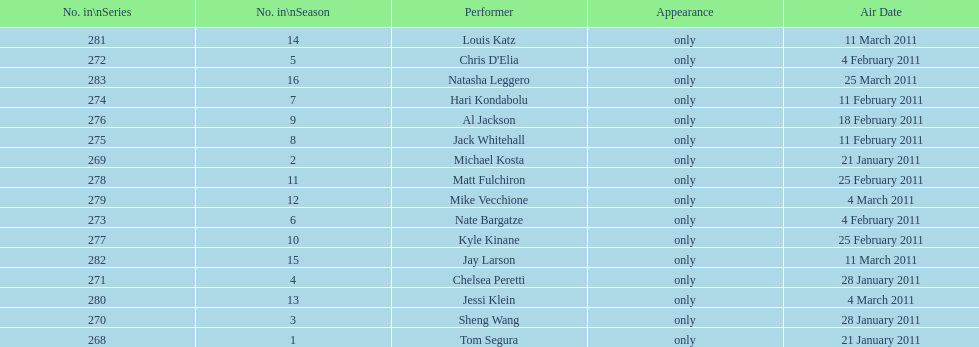How many performers appeared on the air date 21 january 2011? 2. 